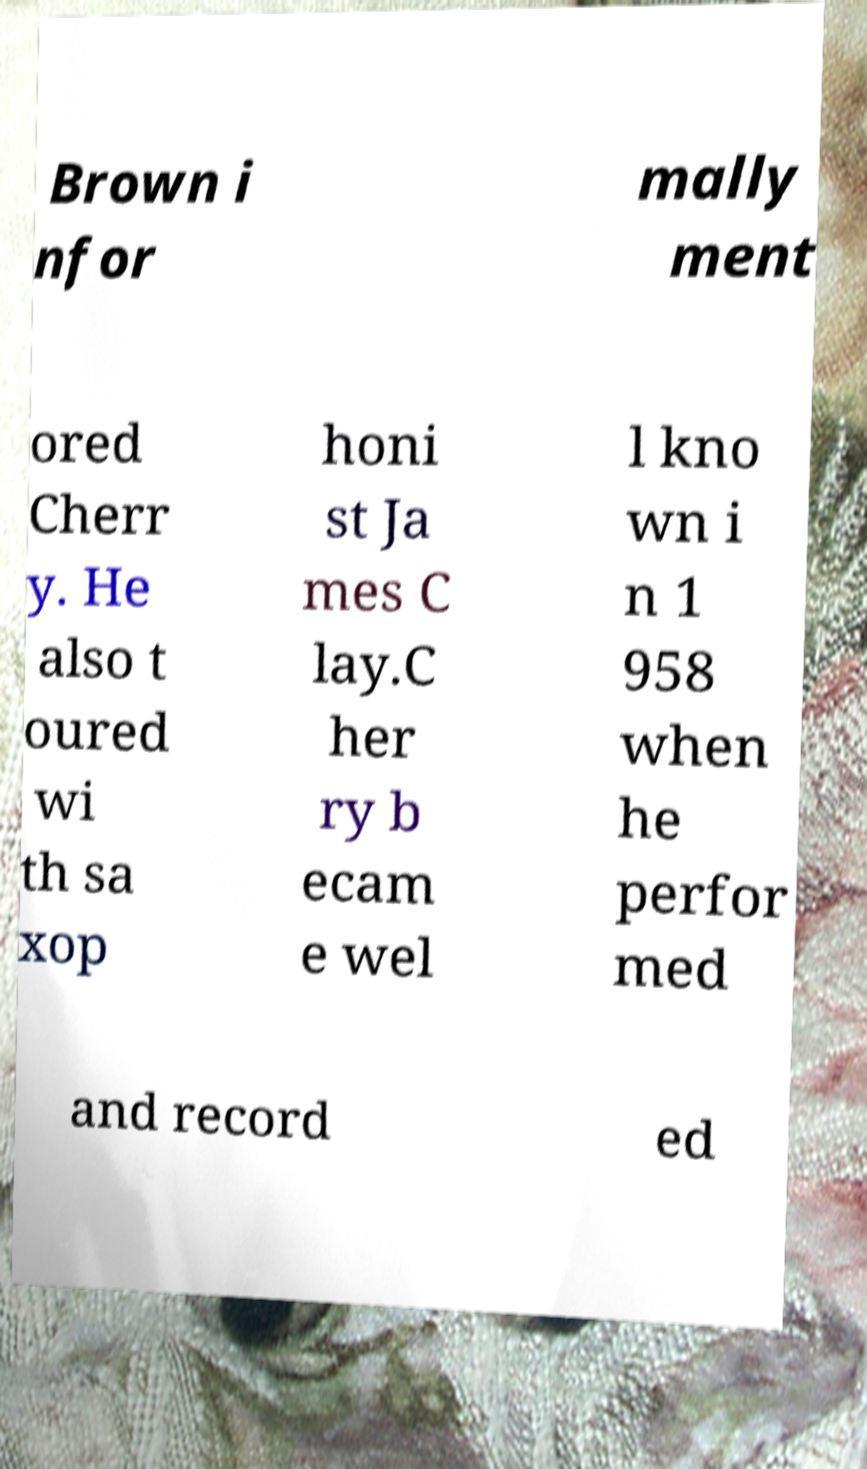Could you extract and type out the text from this image? Brown i nfor mally ment ored Cherr y. He also t oured wi th sa xop honi st Ja mes C lay.C her ry b ecam e wel l kno wn i n 1 958 when he perfor med and record ed 